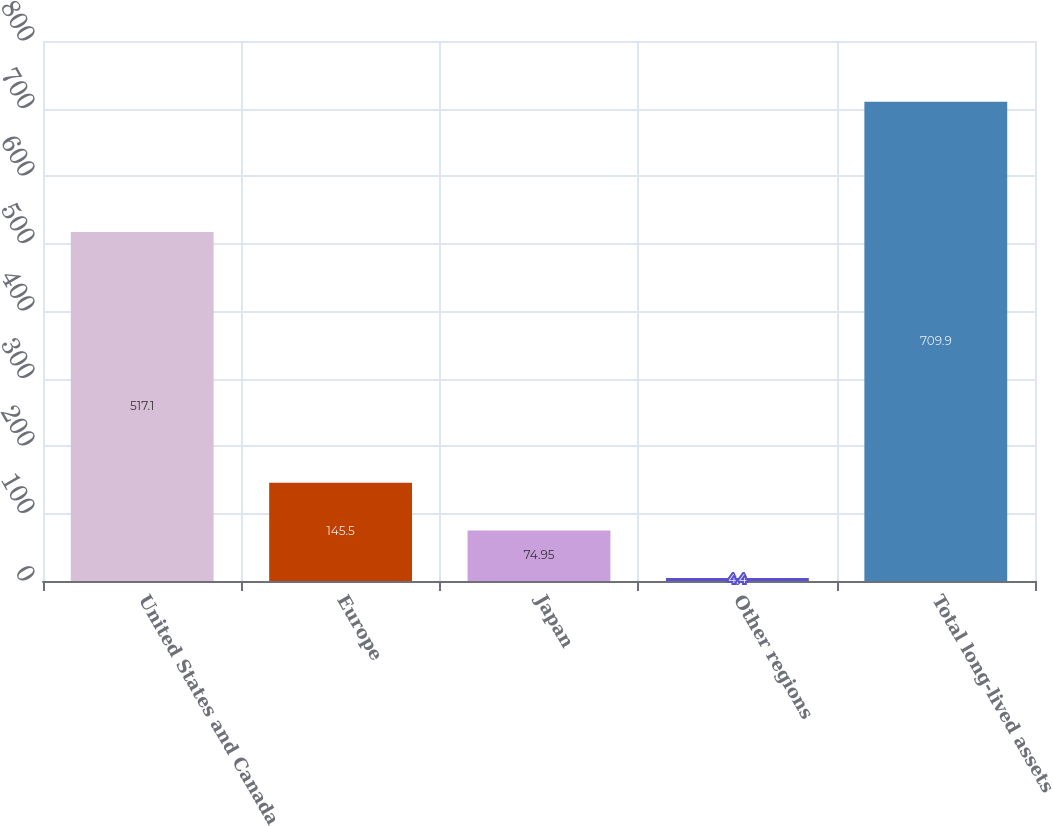Convert chart to OTSL. <chart><loc_0><loc_0><loc_500><loc_500><bar_chart><fcel>United States and Canada<fcel>Europe<fcel>Japan<fcel>Other regions<fcel>Total long-lived assets<nl><fcel>517.1<fcel>145.5<fcel>74.95<fcel>4.4<fcel>709.9<nl></chart> 